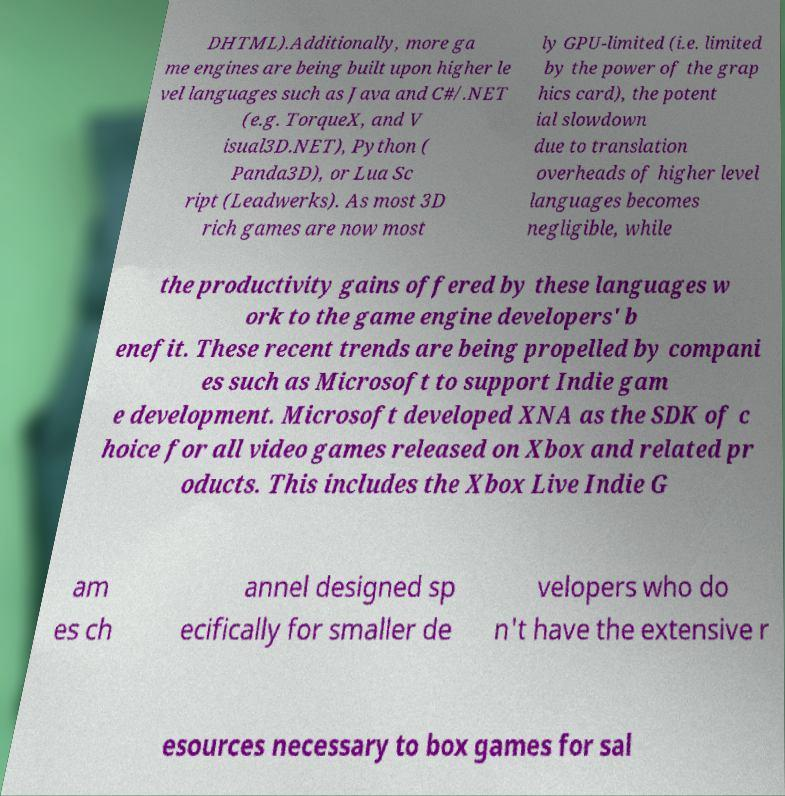What messages or text are displayed in this image? I need them in a readable, typed format. DHTML).Additionally, more ga me engines are being built upon higher le vel languages such as Java and C#/.NET (e.g. TorqueX, and V isual3D.NET), Python ( Panda3D), or Lua Sc ript (Leadwerks). As most 3D rich games are now most ly GPU-limited (i.e. limited by the power of the grap hics card), the potent ial slowdown due to translation overheads of higher level languages becomes negligible, while the productivity gains offered by these languages w ork to the game engine developers' b enefit. These recent trends are being propelled by compani es such as Microsoft to support Indie gam e development. Microsoft developed XNA as the SDK of c hoice for all video games released on Xbox and related pr oducts. This includes the Xbox Live Indie G am es ch annel designed sp ecifically for smaller de velopers who do n't have the extensive r esources necessary to box games for sal 